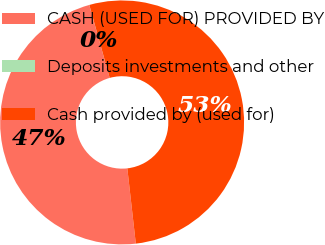Convert chart to OTSL. <chart><loc_0><loc_0><loc_500><loc_500><pie_chart><fcel>CASH (USED FOR) PROVIDED BY<fcel>Deposits investments and other<fcel>Cash provided by (used for)<nl><fcel>47.45%<fcel>0.01%<fcel>52.54%<nl></chart> 